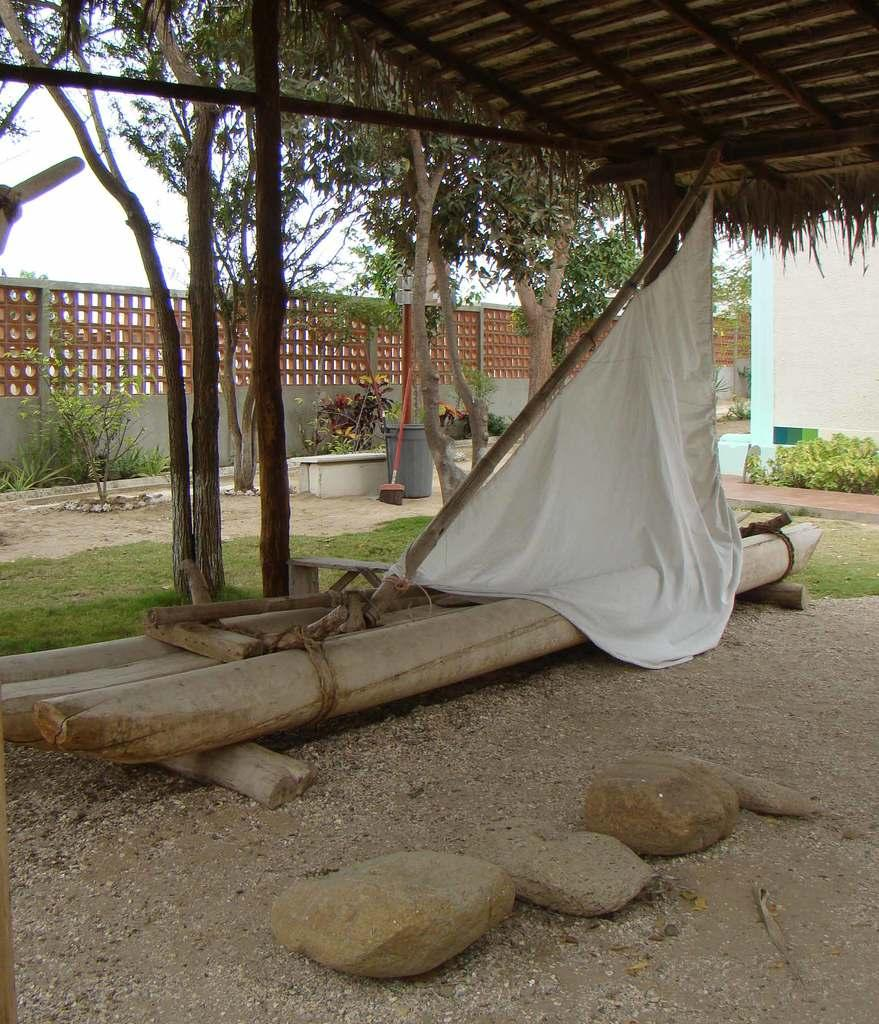What type of structure is in the image? There is a shed in the image. What is attached to the wooden pole near the shed? A white cloth is attached to a wooden pole near the shed. What type of barrier can be seen in the image? There is fencing visible in the image. What type of natural features are present in the image? There are rocks and trees visible in the image. What type of vegetation is present in the image? Plants are present in the image. What type of texture can be seen on the question in the image? There is no question present in the image, so there is no texture to describe. 